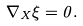<formula> <loc_0><loc_0><loc_500><loc_500>\nabla _ { X } \xi = 0 .</formula> 